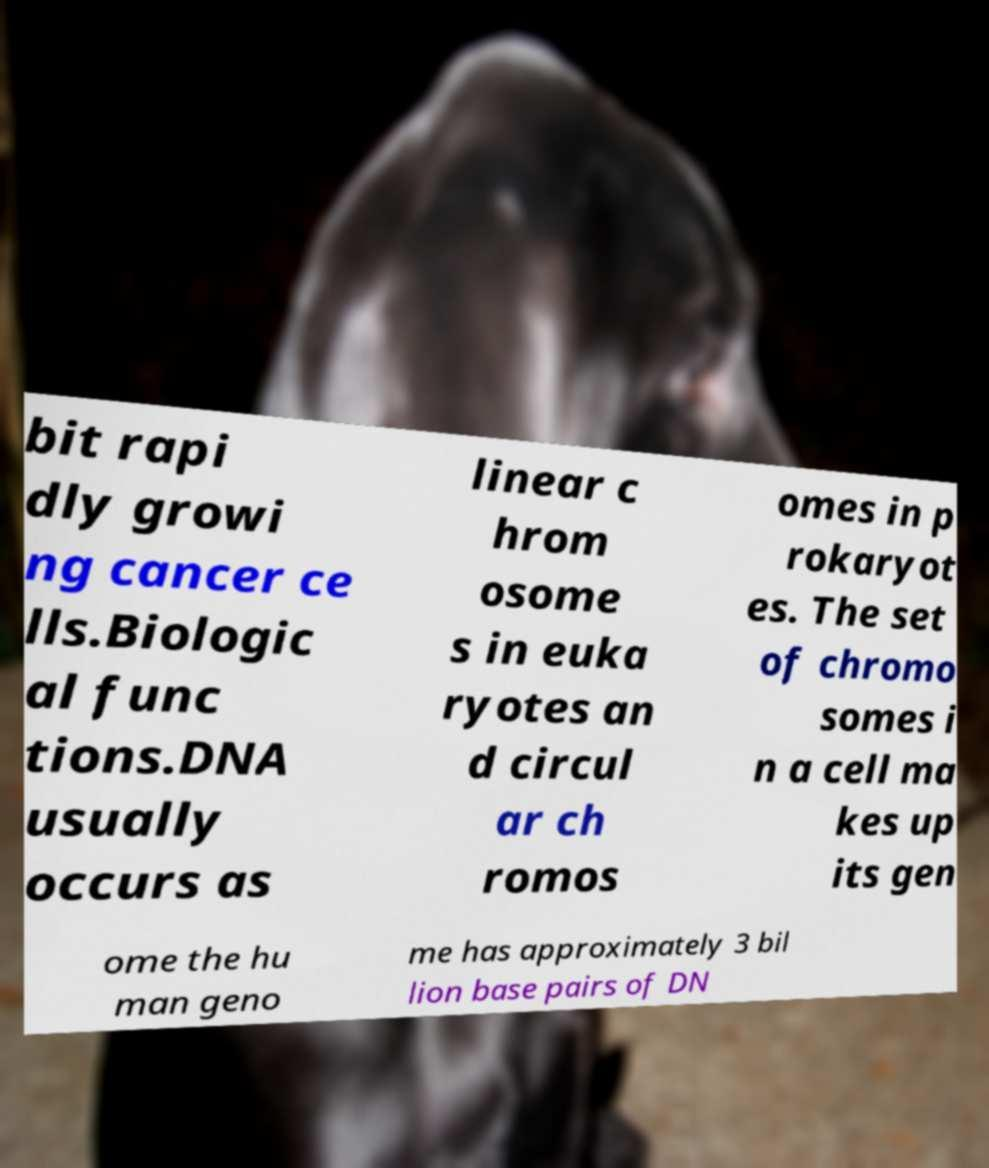Could you extract and type out the text from this image? bit rapi dly growi ng cancer ce lls.Biologic al func tions.DNA usually occurs as linear c hrom osome s in euka ryotes an d circul ar ch romos omes in p rokaryot es. The set of chromo somes i n a cell ma kes up its gen ome the hu man geno me has approximately 3 bil lion base pairs of DN 